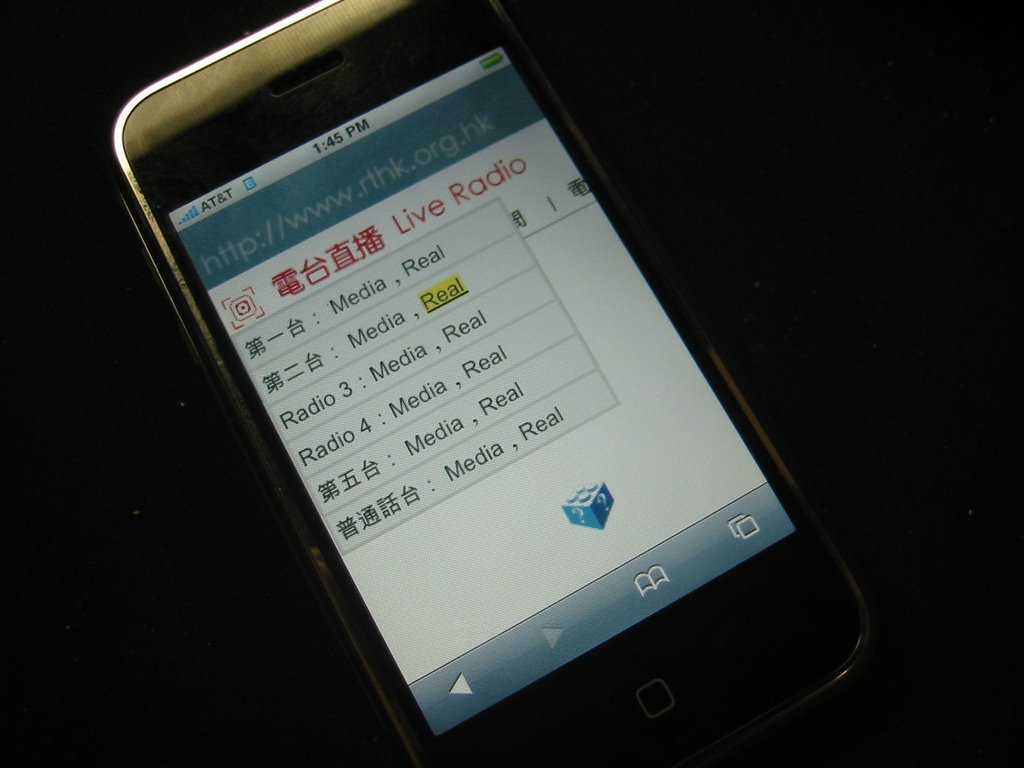Provide a one-sentence caption for the provided image. The image shows a smartphone screen from AT&T displaying the live radio menu of the website 'rthk.org.hk', featuring multiple channels in Chinese. 